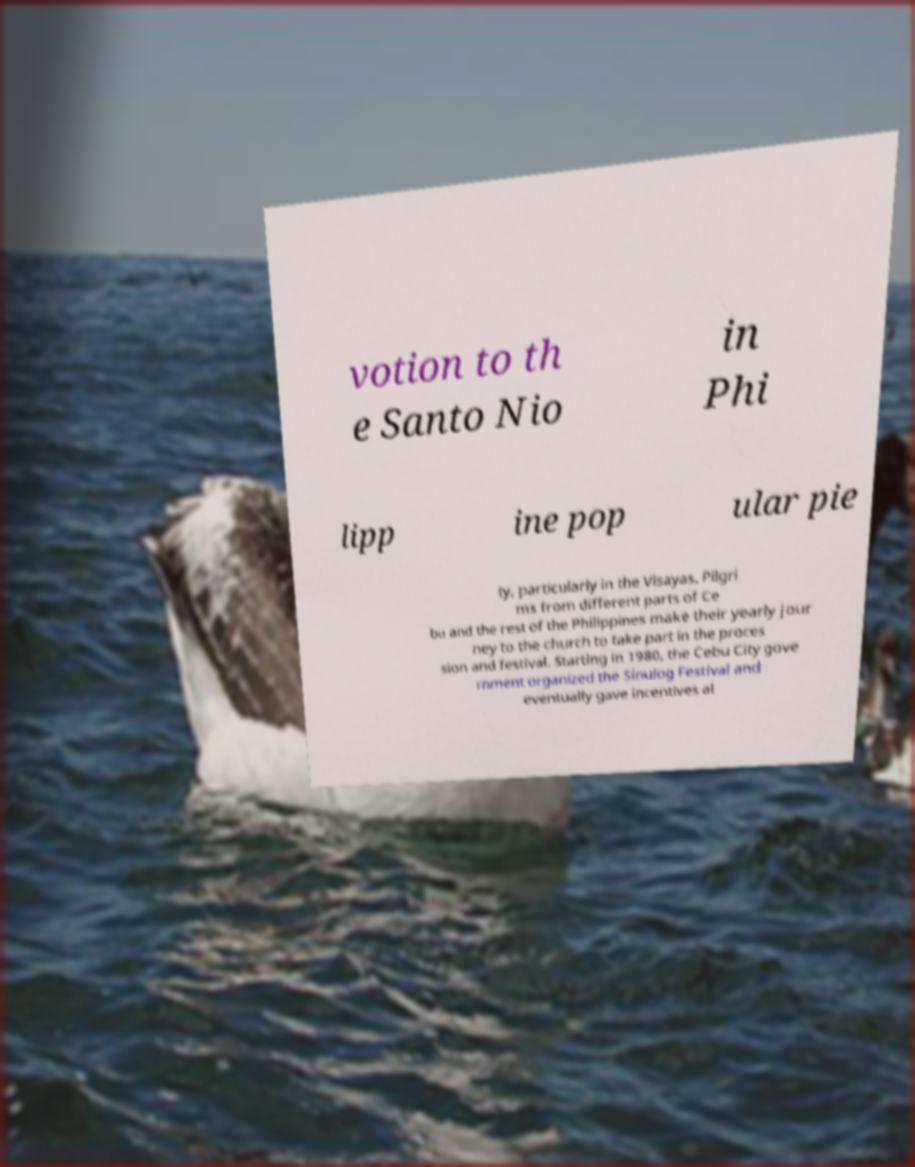For documentation purposes, I need the text within this image transcribed. Could you provide that? votion to th e Santo Nio in Phi lipp ine pop ular pie ty, particularly in the Visayas. Pilgri ms from different parts of Ce bu and the rest of the Philippines make their yearly jour ney to the church to take part in the proces sion and festival. Starting in 1980, the Cebu City gove rnment organized the Sinulog Festival and eventually gave incentives al 